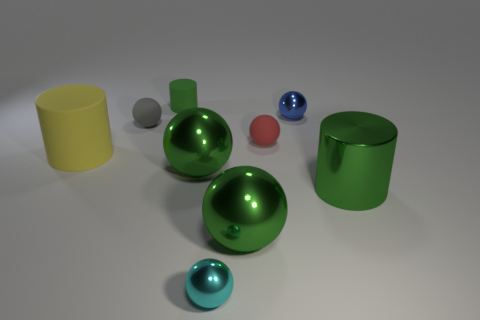How many objects are in the image, and can you categorize them by shape? There are seven objects in the image. We can categorize them by shape: there are three cylinders and four spheres. The cylinders come in two sizes: one is smaller and yellow, and the other two are larger and green. The spheres vary in size and color - one is large and green, there's a medium-sized red one, and two small ones, one blue and one silver. 